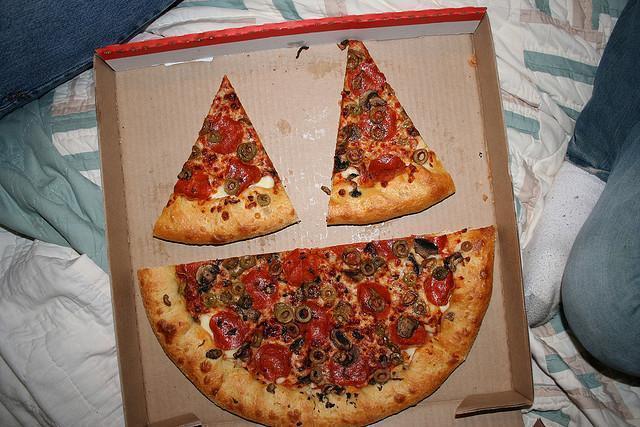Which topping contains the highest level of sodium?
Select the accurate answer and provide explanation: 'Answer: answer
Rationale: rationale.'
Options: Cheese, olive, pepperoni, mushroom. Answer: pepperoni.
Rationale: The meat is filled with salt. 